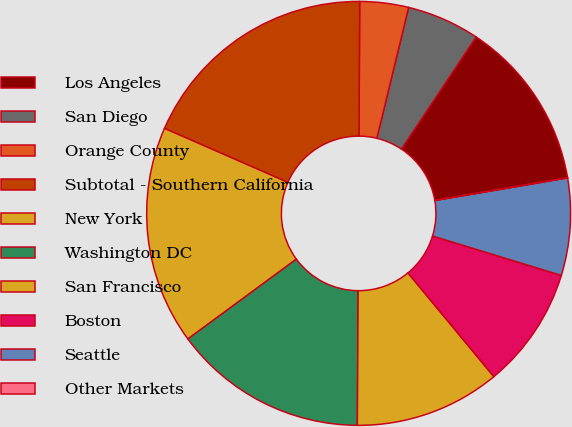Convert chart to OTSL. <chart><loc_0><loc_0><loc_500><loc_500><pie_chart><fcel>Los Angeles<fcel>San Diego<fcel>Orange County<fcel>Subtotal - Southern California<fcel>New York<fcel>Washington DC<fcel>San Francisco<fcel>Boston<fcel>Seattle<fcel>Other Markets<nl><fcel>12.96%<fcel>5.56%<fcel>3.71%<fcel>18.51%<fcel>16.66%<fcel>14.81%<fcel>11.11%<fcel>9.26%<fcel>7.41%<fcel>0.01%<nl></chart> 